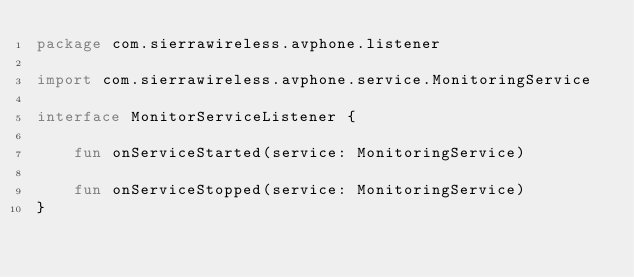<code> <loc_0><loc_0><loc_500><loc_500><_Kotlin_>package com.sierrawireless.avphone.listener

import com.sierrawireless.avphone.service.MonitoringService

interface MonitorServiceListener {

    fun onServiceStarted(service: MonitoringService)

    fun onServiceStopped(service: MonitoringService)
}
</code> 